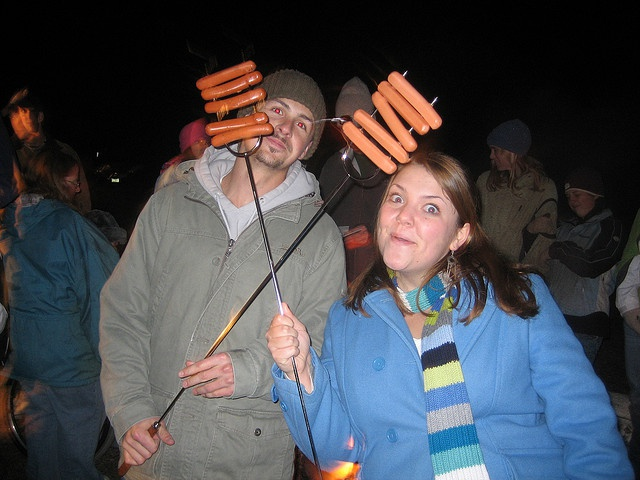Describe the objects in this image and their specific colors. I can see people in black, darkgray, and gray tones, people in black and gray tones, people in black, darkblue, blue, and maroon tones, people in black tones, and people in black and gray tones in this image. 